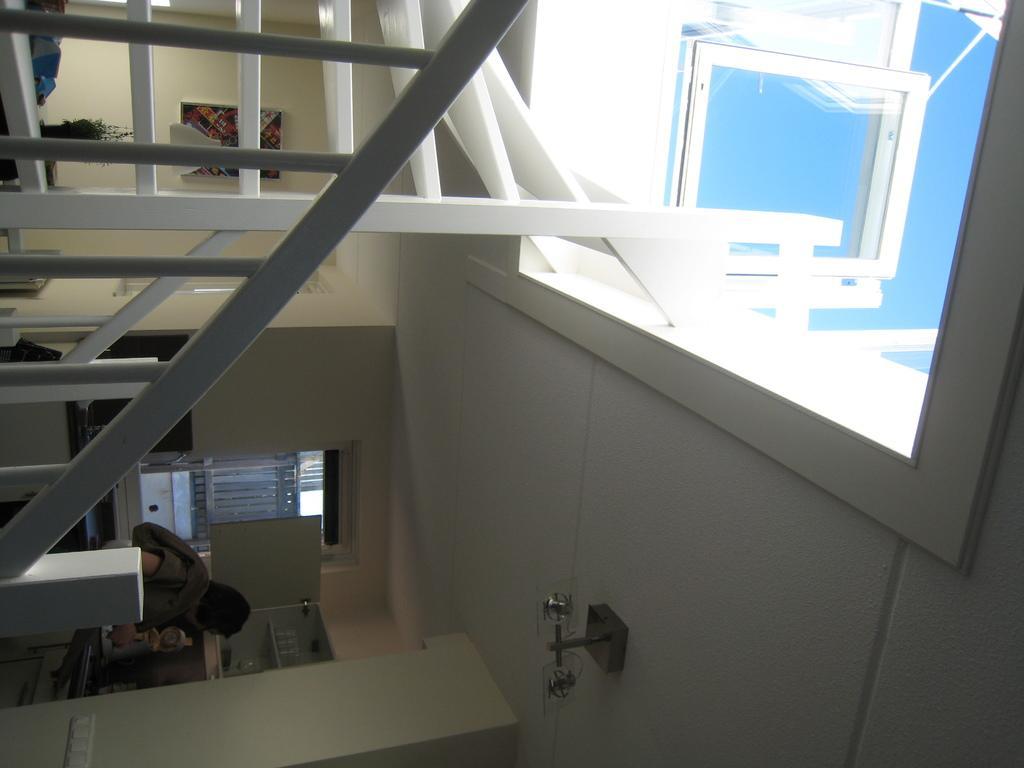How would you summarize this image in a sentence or two? This image is taken indoors. On the right side of the image there is a roof with an open top roof. There is the sky. There is a window. On the left side of the image there are few stairs. There is a railing. There are a few walls. There are a few shelves. There is a window with a window blind and there is a person. 